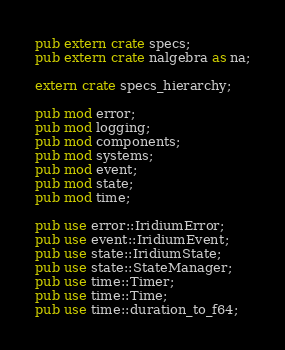<code> <loc_0><loc_0><loc_500><loc_500><_Rust_>
pub extern crate specs;
pub extern crate nalgebra as na;

extern crate specs_hierarchy;

pub mod error;
pub mod logging;
pub mod components;
pub mod systems;
pub mod event;
pub mod state;
pub mod time;

pub use error::IridiumError;
pub use event::IridiumEvent;
pub use state::IridiumState;
pub use state::StateManager;
pub use time::Timer;
pub use time::Time;
pub use time::duration_to_f64;

</code> 